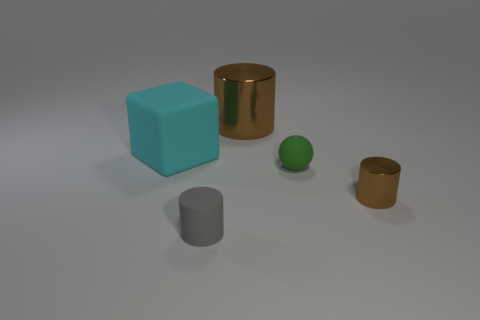Is the size of the matte object that is behind the rubber ball the same as the cylinder that is to the right of the small green object?
Give a very brief answer. No. The small green rubber thing has what shape?
Offer a terse response. Sphere. The shiny thing that is the same color as the large cylinder is what size?
Offer a very short reply. Small. There is a cube that is the same material as the sphere; what is its color?
Your answer should be compact. Cyan. Is the large cylinder made of the same material as the big cube behind the small gray matte cylinder?
Offer a terse response. No. What is the color of the large rubber thing?
Provide a succinct answer. Cyan. The gray thing that is the same material as the green ball is what size?
Keep it short and to the point. Small. What number of tiny brown metallic cylinders are left of the small matte thing on the right side of the small matte thing in front of the green ball?
Make the answer very short. 0. There is a small sphere; is it the same color as the metal cylinder behind the big matte block?
Keep it short and to the point. No. The small shiny thing that is the same color as the large cylinder is what shape?
Ensure brevity in your answer.  Cylinder. 